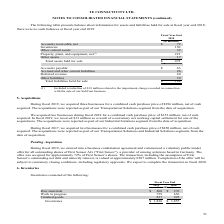According to Te Connectivity's financial document, What was the amount of Inventories in 2019? According to the financial document, $ 1,836 (in millions). The relevant text states: "Inventories $ 1,836 $ 1,857..." Also, In which years was the amount of Inventories calculated for? The document shows two values: 2019 and 2018. From the document: "2019 2018 2019 2018..." Also, What were the components considered when calculating Inventories? The document contains multiple relevant values: Raw materials, Work in progress, Finished goods. From the document: "Raw materials $ 260 $ 276 Finished goods 837 925 Work in progress 739 656..." Additionally, In which year was Raw materials larger? According to the financial document, 2018. The relevant text states: "2019 2018..." Also, can you calculate: What was the change in Work in progress in 2019 from 2018? Based on the calculation: 739-656, the result is 83 (in millions). This is based on the information: "Work in progress 739 656 Work in progress 739 656..." The key data points involved are: 656, 739. Also, can you calculate: What was the percentage change in Work in progress in 2019 from 2018? To answer this question, I need to perform calculations using the financial data. The calculation is: (739-656)/656, which equals 12.65 (percentage). This is based on the information: "Work in progress 739 656 Work in progress 739 656..." The key data points involved are: 656, 739. 